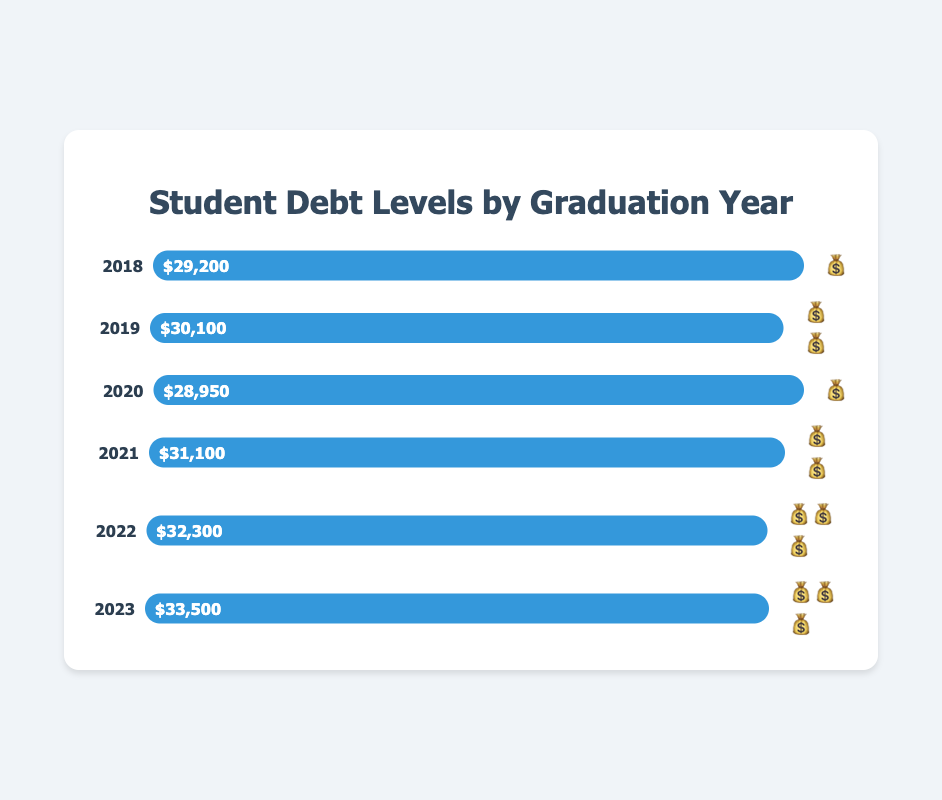what is the title of the figure? The title can be found at the top of the chart. It helps us understand what the entire figure is about. The title in this case reads "Student Debt Levels by Graduation Year".
Answer: Student Debt Levels by Graduation Year How much was the average debt in 2020? Look for the bar labeled "2020" and read the value indicated on the bar. The debt amount is displayed within the bar.
Answer: $28,950 In which years do we see two money bag emojis? Identify the bars that have two money bag emojis next to them. These emojis represent specific levels of debt.
Answer: 2019 and 2021 What is the trend in student debt levels from 2018 to 2023? Examine the heights of the bars consecutively from 2018 to 2023. Observe whether they are generally increasing, decreasing, or staying the same.
Answer: Increasing Which year had the highest average student debt? Find the bar with the greatest length and check the year it represents.
Answer: 2023 By how much did the average student debt change from 2019 to 2020? Subtract the average debt in 2020 from the average debt in 2019. ($30,100 - $28,950).
Answer: $1,150 decrease How many years have a higher average debt than 2020? Compare the debt values of each year against the debt value for 2020. Count the number of years that have a higher debt.
Answer: 3 years (2019, 2021, 2022, and 2023) What is the average debt level over the years shown? Add up the average debts for each year and divide by the number of years. ($29,200 + $30,100 + $28,950 + $31,100 + $32,300 + $33,500) / 6.
Answer: $30,858.33 What does the emoji representation indicate in this chart? The number of money bag emojis next to each bar provide a visual cue for the debt level: more money bags signify higher debt levels.
Answer: More emojis = Higher debt 